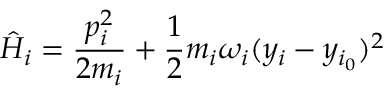<formula> <loc_0><loc_0><loc_500><loc_500>\hat { H } _ { i } = \frac { p _ { i } ^ { 2 } } { 2 m _ { i } } + \frac { 1 } { 2 } m _ { i } \omega _ { i } ( y _ { i } - y _ { i _ { 0 } } ) ^ { 2 }</formula> 